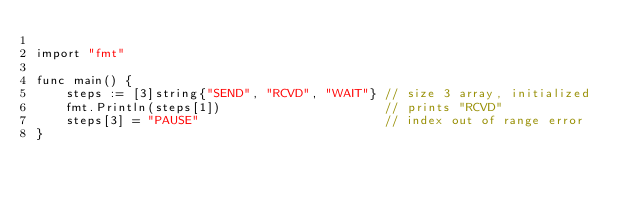Convert code to text. <code><loc_0><loc_0><loc_500><loc_500><_Go_>
import "fmt"

func main() {
	steps := [3]string{"SEND", "RCVD", "WAIT"} // size 3 array, initialized
	fmt.Println(steps[1])                      // prints "RCVD"
	steps[3] = "PAUSE"                         // index out of range error
}
</code> 